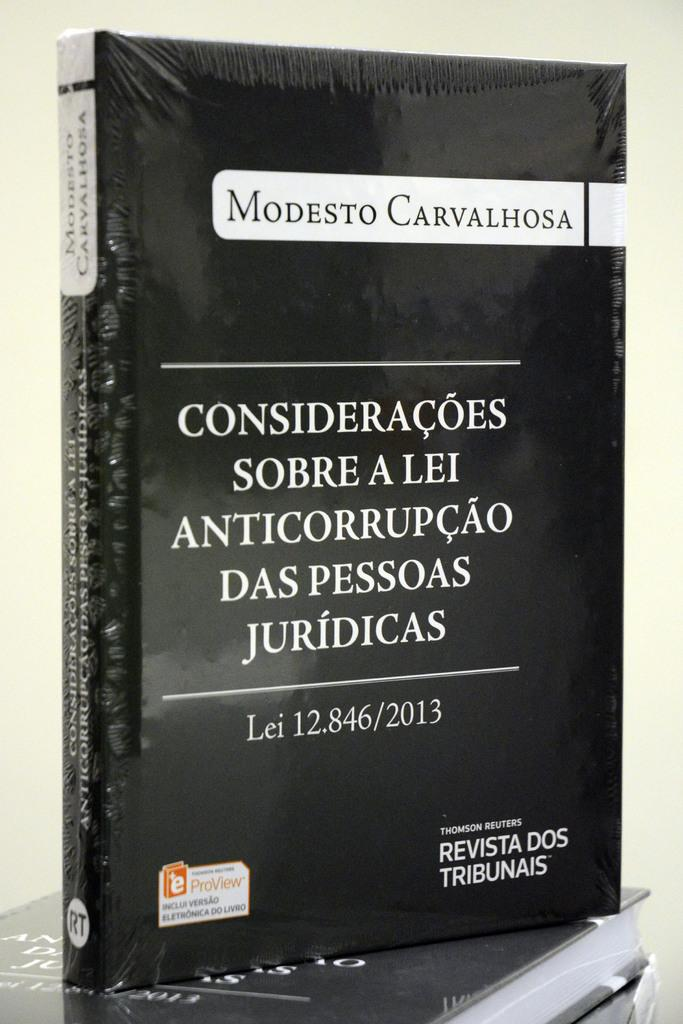<image>
Create a compact narrative representing the image presented. A black book is standing on edge with the name Modesto Carvalhosa on the cover. 